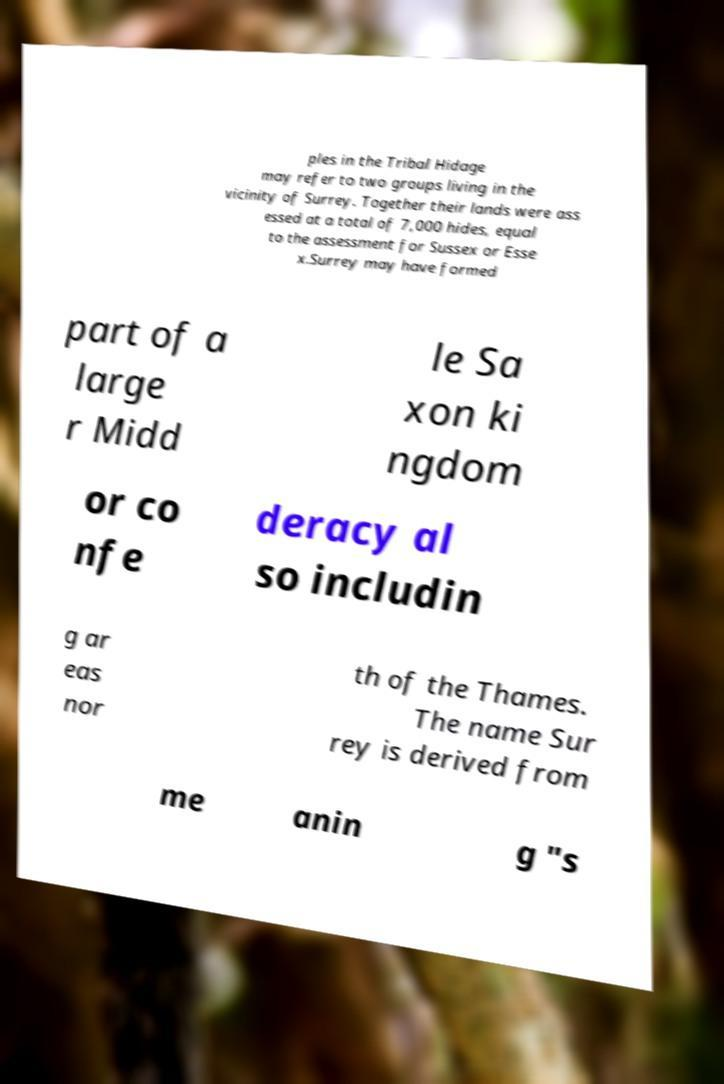Can you accurately transcribe the text from the provided image for me? ples in the Tribal Hidage may refer to two groups living in the vicinity of Surrey. Together their lands were ass essed at a total of 7,000 hides, equal to the assessment for Sussex or Esse x.Surrey may have formed part of a large r Midd le Sa xon ki ngdom or co nfe deracy al so includin g ar eas nor th of the Thames. The name Sur rey is derived from me anin g "s 